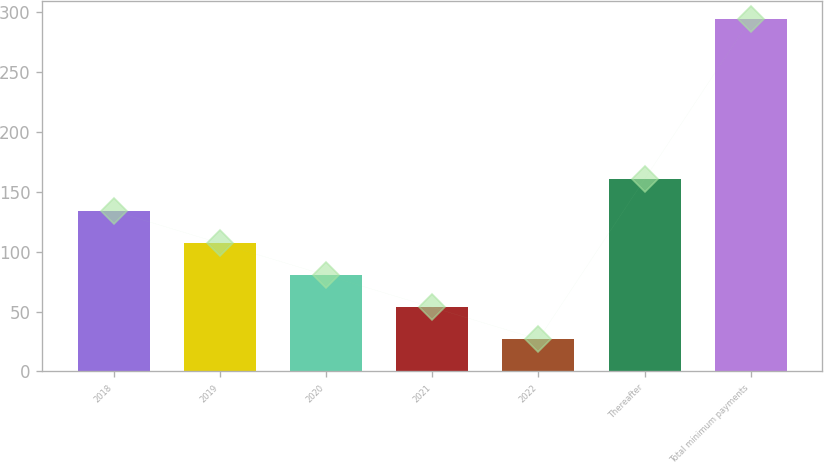Convert chart. <chart><loc_0><loc_0><loc_500><loc_500><bar_chart><fcel>2018<fcel>2019<fcel>2020<fcel>2021<fcel>2022<fcel>Thereafter<fcel>Total minimum payments<nl><fcel>133.8<fcel>107.05<fcel>80.3<fcel>53.55<fcel>26.8<fcel>160.55<fcel>294.3<nl></chart> 